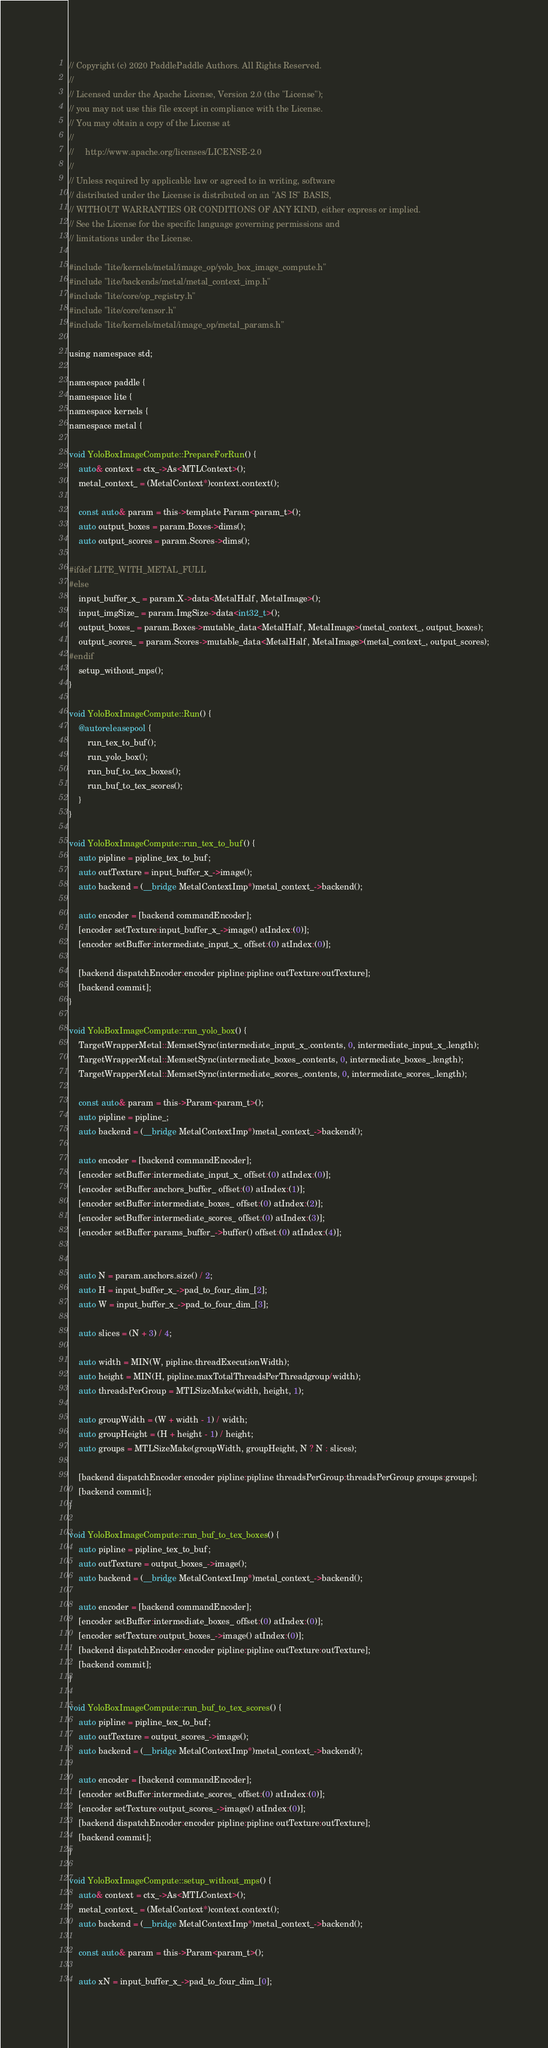Convert code to text. <code><loc_0><loc_0><loc_500><loc_500><_ObjectiveC_>// Copyright (c) 2020 PaddlePaddle Authors. All Rights Reserved.
//
// Licensed under the Apache License, Version 2.0 (the "License");
// you may not use this file except in compliance with the License.
// You may obtain a copy of the License at
//
//     http://www.apache.org/licenses/LICENSE-2.0
//
// Unless required by applicable law or agreed to in writing, software
// distributed under the License is distributed on an "AS IS" BASIS,
// WITHOUT WARRANTIES OR CONDITIONS OF ANY KIND, either express or implied.
// See the License for the specific language governing permissions and
// limitations under the License.

#include "lite/kernels/metal/image_op/yolo_box_image_compute.h"
#include "lite/backends/metal/metal_context_imp.h"
#include "lite/core/op_registry.h"
#include "lite/core/tensor.h"
#include "lite/kernels/metal/image_op/metal_params.h"

using namespace std;

namespace paddle {
namespace lite {
namespace kernels {
namespace metal {

void YoloBoxImageCompute::PrepareForRun() {
    auto& context = ctx_->As<MTLContext>();
    metal_context_ = (MetalContext*)context.context();

    const auto& param = this->template Param<param_t>();
    auto output_boxes = param.Boxes->dims();
    auto output_scores = param.Scores->dims();

#ifdef LITE_WITH_METAL_FULL
#else
    input_buffer_x_ = param.X->data<MetalHalf, MetalImage>();
    input_imgSize_ = param.ImgSize->data<int32_t>();
    output_boxes_ = param.Boxes->mutable_data<MetalHalf, MetalImage>(metal_context_, output_boxes);
    output_scores_ = param.Scores->mutable_data<MetalHalf, MetalImage>(metal_context_, output_scores);
#endif
    setup_without_mps();
}

void YoloBoxImageCompute::Run() {
    @autoreleasepool {
        run_tex_to_buf();
        run_yolo_box();
        run_buf_to_tex_boxes();
        run_buf_to_tex_scores();
    }
}

void YoloBoxImageCompute::run_tex_to_buf() {
    auto pipline = pipline_tex_to_buf;
    auto outTexture = input_buffer_x_->image();
    auto backend = (__bridge MetalContextImp*)metal_context_->backend();

    auto encoder = [backend commandEncoder];
    [encoder setTexture:input_buffer_x_->image() atIndex:(0)];
    [encoder setBuffer:intermediate_input_x_ offset:(0) atIndex:(0)];

    [backend dispatchEncoder:encoder pipline:pipline outTexture:outTexture];
    [backend commit];
}

void YoloBoxImageCompute::run_yolo_box() {
    TargetWrapperMetal::MemsetSync(intermediate_input_x_.contents, 0, intermediate_input_x_.length);
    TargetWrapperMetal::MemsetSync(intermediate_boxes_.contents, 0, intermediate_boxes_.length);
    TargetWrapperMetal::MemsetSync(intermediate_scores_.contents, 0, intermediate_scores_.length);
    
    const auto& param = this->Param<param_t>();
    auto pipline = pipline_;
    auto backend = (__bridge MetalContextImp*)metal_context_->backend();

    auto encoder = [backend commandEncoder];
    [encoder setBuffer:intermediate_input_x_ offset:(0) atIndex:(0)];
    [encoder setBuffer:anchors_buffer_ offset:(0) atIndex:(1)];
    [encoder setBuffer:intermediate_boxes_ offset:(0) atIndex:(2)];
    [encoder setBuffer:intermediate_scores_ offset:(0) atIndex:(3)];
    [encoder setBuffer:params_buffer_->buffer() offset:(0) atIndex:(4)];
    
    
    auto N = param.anchors.size() / 2;
    auto H = input_buffer_x_->pad_to_four_dim_[2];
    auto W = input_buffer_x_->pad_to_four_dim_[3];
    
    auto slices = (N + 3) / 4;
    
    auto width = MIN(W, pipline.threadExecutionWidth);
    auto height = MIN(H, pipline.maxTotalThreadsPerThreadgroup/width);
    auto threadsPerGroup = MTLSizeMake(width, height, 1);
        
    auto groupWidth = (W + width - 1) / width;
    auto groupHeight = (H + height - 1) / height;
    auto groups = MTLSizeMake(groupWidth, groupHeight, N ? N : slices);
    
    [backend dispatchEncoder:encoder pipline:pipline threadsPerGroup:threadsPerGroup groups:groups];
    [backend commit];
}

void YoloBoxImageCompute::run_buf_to_tex_boxes() {
    auto pipline = pipline_tex_to_buf;
    auto outTexture = output_boxes_->image();
    auto backend = (__bridge MetalContextImp*)metal_context_->backend();
    
    auto encoder = [backend commandEncoder];
    [encoder setBuffer:intermediate_boxes_ offset:(0) atIndex:(0)];
    [encoder setTexture:output_boxes_->image() atIndex:(0)];
    [backend dispatchEncoder:encoder pipline:pipline outTexture:outTexture];
    [backend commit];
}

void YoloBoxImageCompute::run_buf_to_tex_scores() {
    auto pipline = pipline_tex_to_buf;
    auto outTexture = output_scores_->image();
    auto backend = (__bridge MetalContextImp*)metal_context_->backend();
    
    auto encoder = [backend commandEncoder];
    [encoder setBuffer:intermediate_scores_ offset:(0) atIndex:(0)];
    [encoder setTexture:output_scores_->image() atIndex:(0)];
    [backend dispatchEncoder:encoder pipline:pipline outTexture:outTexture];
    [backend commit];
}

void YoloBoxImageCompute::setup_without_mps() {
    auto& context = ctx_->As<MTLContext>();
    metal_context_ = (MetalContext*)context.context();
    auto backend = (__bridge MetalContextImp*)metal_context_->backend();

    const auto& param = this->Param<param_t>();
    
    auto xN = input_buffer_x_->pad_to_four_dim_[0];</code> 